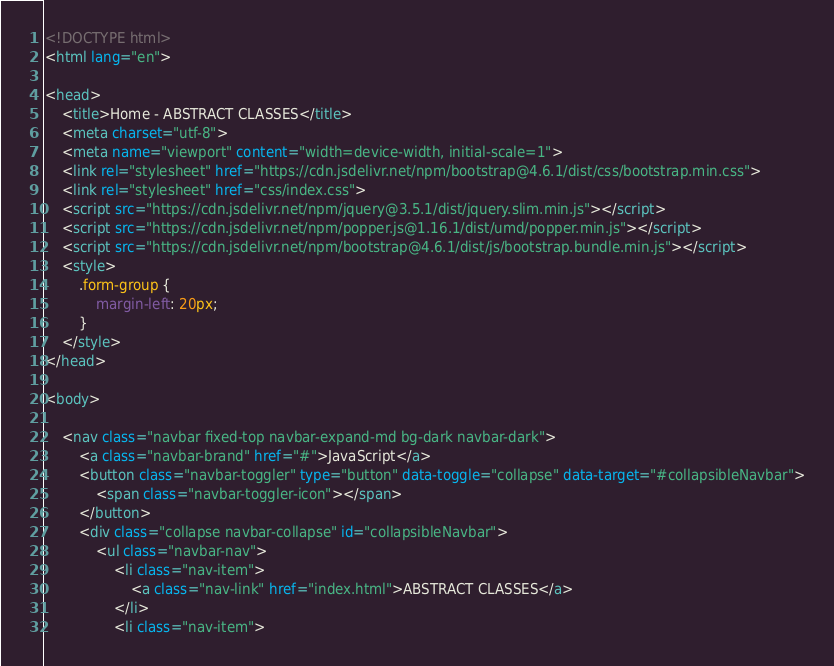<code> <loc_0><loc_0><loc_500><loc_500><_HTML_><!DOCTYPE html>
<html lang="en">

<head>
    <title>Home - ABSTRACT CLASSES</title>
    <meta charset="utf-8">
    <meta name="viewport" content="width=device-width, initial-scale=1">
    <link rel="stylesheet" href="https://cdn.jsdelivr.net/npm/bootstrap@4.6.1/dist/css/bootstrap.min.css">
    <link rel="stylesheet" href="css/index.css">
    <script src="https://cdn.jsdelivr.net/npm/jquery@3.5.1/dist/jquery.slim.min.js"></script>
    <script src="https://cdn.jsdelivr.net/npm/popper.js@1.16.1/dist/umd/popper.min.js"></script>
    <script src="https://cdn.jsdelivr.net/npm/bootstrap@4.6.1/dist/js/bootstrap.bundle.min.js"></script>
    <style>
        .form-group {
            margin-left: 20px;
        }
    </style>
</head>

<body>

    <nav class="navbar fixed-top navbar-expand-md bg-dark navbar-dark">
        <a class="navbar-brand" href="#">JavaScript</a>
        <button class="navbar-toggler" type="button" data-toggle="collapse" data-target="#collapsibleNavbar">
            <span class="navbar-toggler-icon"></span>
        </button>
        <div class="collapse navbar-collapse" id="collapsibleNavbar">
            <ul class="navbar-nav">
                <li class="nav-item">
                    <a class="nav-link" href="index.html">ABSTRACT CLASSES</a>
                </li>
                <li class="nav-item"></code> 